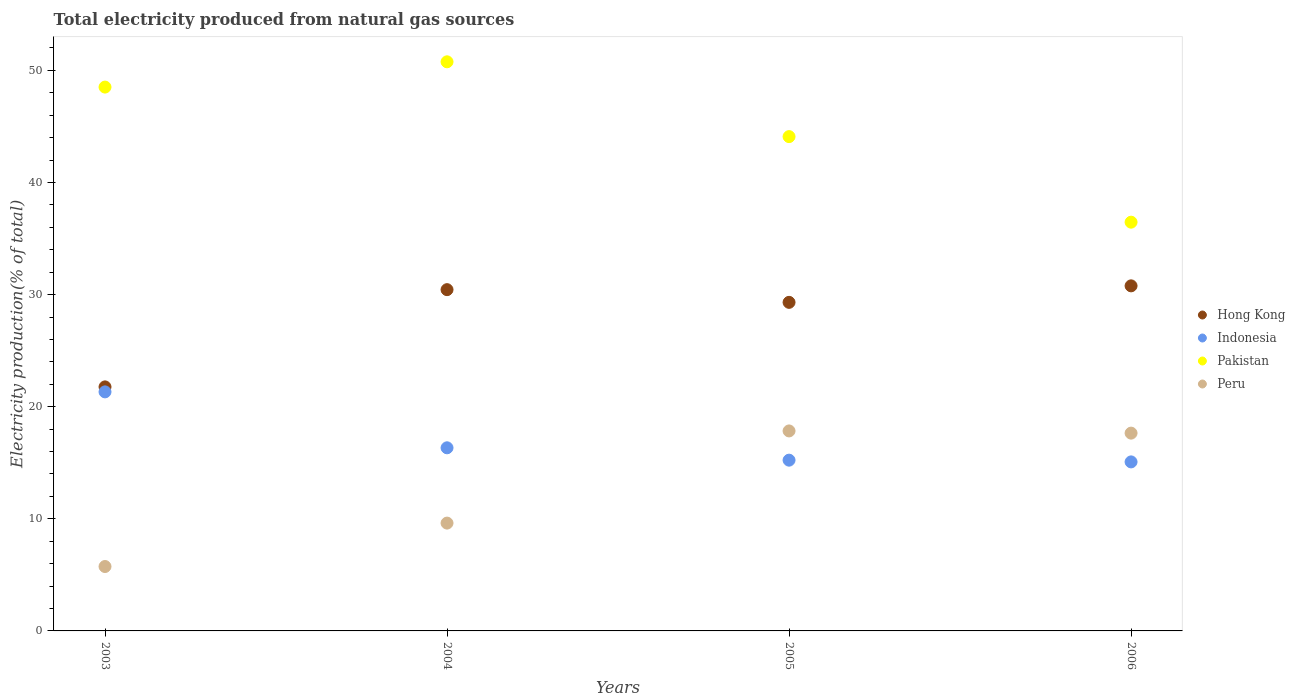Is the number of dotlines equal to the number of legend labels?
Provide a succinct answer. Yes. What is the total electricity produced in Pakistan in 2005?
Keep it short and to the point. 44.1. Across all years, what is the maximum total electricity produced in Peru?
Offer a very short reply. 17.84. Across all years, what is the minimum total electricity produced in Indonesia?
Make the answer very short. 15.08. What is the total total electricity produced in Peru in the graph?
Offer a very short reply. 50.85. What is the difference between the total electricity produced in Pakistan in 2004 and that in 2005?
Provide a short and direct response. 6.67. What is the difference between the total electricity produced in Peru in 2006 and the total electricity produced in Hong Kong in 2005?
Offer a very short reply. -11.67. What is the average total electricity produced in Indonesia per year?
Provide a short and direct response. 16.99. In the year 2005, what is the difference between the total electricity produced in Pakistan and total electricity produced in Peru?
Give a very brief answer. 26.26. In how many years, is the total electricity produced in Hong Kong greater than 24 %?
Make the answer very short. 3. What is the ratio of the total electricity produced in Peru in 2003 to that in 2005?
Provide a short and direct response. 0.32. Is the difference between the total electricity produced in Pakistan in 2004 and 2005 greater than the difference between the total electricity produced in Peru in 2004 and 2005?
Offer a very short reply. Yes. What is the difference between the highest and the second highest total electricity produced in Pakistan?
Offer a terse response. 2.25. What is the difference between the highest and the lowest total electricity produced in Indonesia?
Offer a very short reply. 6.25. In how many years, is the total electricity produced in Indonesia greater than the average total electricity produced in Indonesia taken over all years?
Provide a short and direct response. 1. Is the sum of the total electricity produced in Hong Kong in 2004 and 2006 greater than the maximum total electricity produced in Pakistan across all years?
Your answer should be compact. Yes. Does the total electricity produced in Pakistan monotonically increase over the years?
Ensure brevity in your answer.  No. Is the total electricity produced in Peru strictly greater than the total electricity produced in Pakistan over the years?
Ensure brevity in your answer.  No. What is the difference between two consecutive major ticks on the Y-axis?
Offer a terse response. 10. Are the values on the major ticks of Y-axis written in scientific E-notation?
Keep it short and to the point. No. Does the graph contain any zero values?
Your response must be concise. No. How many legend labels are there?
Your response must be concise. 4. What is the title of the graph?
Your answer should be compact. Total electricity produced from natural gas sources. Does "Sudan" appear as one of the legend labels in the graph?
Make the answer very short. No. What is the Electricity production(% of total) of Hong Kong in 2003?
Keep it short and to the point. 21.77. What is the Electricity production(% of total) of Indonesia in 2003?
Give a very brief answer. 21.32. What is the Electricity production(% of total) of Pakistan in 2003?
Offer a very short reply. 48.51. What is the Electricity production(% of total) in Peru in 2003?
Provide a succinct answer. 5.75. What is the Electricity production(% of total) of Hong Kong in 2004?
Your answer should be very brief. 30.44. What is the Electricity production(% of total) of Indonesia in 2004?
Your answer should be compact. 16.34. What is the Electricity production(% of total) in Pakistan in 2004?
Offer a terse response. 50.77. What is the Electricity production(% of total) in Peru in 2004?
Your response must be concise. 9.62. What is the Electricity production(% of total) in Hong Kong in 2005?
Your response must be concise. 29.31. What is the Electricity production(% of total) in Indonesia in 2005?
Give a very brief answer. 15.23. What is the Electricity production(% of total) in Pakistan in 2005?
Provide a short and direct response. 44.1. What is the Electricity production(% of total) of Peru in 2005?
Your answer should be very brief. 17.84. What is the Electricity production(% of total) of Hong Kong in 2006?
Offer a terse response. 30.78. What is the Electricity production(% of total) of Indonesia in 2006?
Your answer should be compact. 15.08. What is the Electricity production(% of total) in Pakistan in 2006?
Provide a short and direct response. 36.46. What is the Electricity production(% of total) of Peru in 2006?
Make the answer very short. 17.64. Across all years, what is the maximum Electricity production(% of total) in Hong Kong?
Provide a succinct answer. 30.78. Across all years, what is the maximum Electricity production(% of total) in Indonesia?
Provide a succinct answer. 21.32. Across all years, what is the maximum Electricity production(% of total) of Pakistan?
Make the answer very short. 50.77. Across all years, what is the maximum Electricity production(% of total) of Peru?
Ensure brevity in your answer.  17.84. Across all years, what is the minimum Electricity production(% of total) of Hong Kong?
Provide a short and direct response. 21.77. Across all years, what is the minimum Electricity production(% of total) of Indonesia?
Ensure brevity in your answer.  15.08. Across all years, what is the minimum Electricity production(% of total) of Pakistan?
Your answer should be very brief. 36.46. Across all years, what is the minimum Electricity production(% of total) of Peru?
Offer a terse response. 5.75. What is the total Electricity production(% of total) in Hong Kong in the graph?
Your answer should be compact. 112.3. What is the total Electricity production(% of total) of Indonesia in the graph?
Your answer should be compact. 67.97. What is the total Electricity production(% of total) in Pakistan in the graph?
Your answer should be very brief. 179.84. What is the total Electricity production(% of total) in Peru in the graph?
Provide a short and direct response. 50.85. What is the difference between the Electricity production(% of total) of Hong Kong in 2003 and that in 2004?
Ensure brevity in your answer.  -8.67. What is the difference between the Electricity production(% of total) in Indonesia in 2003 and that in 2004?
Ensure brevity in your answer.  4.99. What is the difference between the Electricity production(% of total) of Pakistan in 2003 and that in 2004?
Provide a succinct answer. -2.25. What is the difference between the Electricity production(% of total) of Peru in 2003 and that in 2004?
Offer a very short reply. -3.87. What is the difference between the Electricity production(% of total) in Hong Kong in 2003 and that in 2005?
Your response must be concise. -7.54. What is the difference between the Electricity production(% of total) in Indonesia in 2003 and that in 2005?
Your response must be concise. 6.09. What is the difference between the Electricity production(% of total) of Pakistan in 2003 and that in 2005?
Your answer should be very brief. 4.42. What is the difference between the Electricity production(% of total) of Peru in 2003 and that in 2005?
Make the answer very short. -12.09. What is the difference between the Electricity production(% of total) in Hong Kong in 2003 and that in 2006?
Your answer should be very brief. -9.01. What is the difference between the Electricity production(% of total) in Indonesia in 2003 and that in 2006?
Your answer should be compact. 6.25. What is the difference between the Electricity production(% of total) of Pakistan in 2003 and that in 2006?
Give a very brief answer. 12.05. What is the difference between the Electricity production(% of total) in Peru in 2003 and that in 2006?
Keep it short and to the point. -11.9. What is the difference between the Electricity production(% of total) in Hong Kong in 2004 and that in 2005?
Your answer should be very brief. 1.13. What is the difference between the Electricity production(% of total) of Indonesia in 2004 and that in 2005?
Offer a terse response. 1.1. What is the difference between the Electricity production(% of total) of Pakistan in 2004 and that in 2005?
Your answer should be compact. 6.67. What is the difference between the Electricity production(% of total) of Peru in 2004 and that in 2005?
Offer a very short reply. -8.22. What is the difference between the Electricity production(% of total) of Hong Kong in 2004 and that in 2006?
Offer a terse response. -0.34. What is the difference between the Electricity production(% of total) of Indonesia in 2004 and that in 2006?
Provide a succinct answer. 1.26. What is the difference between the Electricity production(% of total) in Pakistan in 2004 and that in 2006?
Your answer should be very brief. 14.31. What is the difference between the Electricity production(% of total) in Peru in 2004 and that in 2006?
Make the answer very short. -8.03. What is the difference between the Electricity production(% of total) in Hong Kong in 2005 and that in 2006?
Give a very brief answer. -1.47. What is the difference between the Electricity production(% of total) of Indonesia in 2005 and that in 2006?
Your answer should be compact. 0.16. What is the difference between the Electricity production(% of total) in Pakistan in 2005 and that in 2006?
Your answer should be compact. 7.63. What is the difference between the Electricity production(% of total) in Peru in 2005 and that in 2006?
Offer a very short reply. 0.2. What is the difference between the Electricity production(% of total) of Hong Kong in 2003 and the Electricity production(% of total) of Indonesia in 2004?
Provide a succinct answer. 5.43. What is the difference between the Electricity production(% of total) in Hong Kong in 2003 and the Electricity production(% of total) in Pakistan in 2004?
Your answer should be very brief. -29. What is the difference between the Electricity production(% of total) in Hong Kong in 2003 and the Electricity production(% of total) in Peru in 2004?
Make the answer very short. 12.15. What is the difference between the Electricity production(% of total) of Indonesia in 2003 and the Electricity production(% of total) of Pakistan in 2004?
Provide a succinct answer. -29.44. What is the difference between the Electricity production(% of total) of Indonesia in 2003 and the Electricity production(% of total) of Peru in 2004?
Give a very brief answer. 11.71. What is the difference between the Electricity production(% of total) of Pakistan in 2003 and the Electricity production(% of total) of Peru in 2004?
Your answer should be very brief. 38.89. What is the difference between the Electricity production(% of total) in Hong Kong in 2003 and the Electricity production(% of total) in Indonesia in 2005?
Your answer should be compact. 6.54. What is the difference between the Electricity production(% of total) of Hong Kong in 2003 and the Electricity production(% of total) of Pakistan in 2005?
Keep it short and to the point. -22.33. What is the difference between the Electricity production(% of total) of Hong Kong in 2003 and the Electricity production(% of total) of Peru in 2005?
Your answer should be very brief. 3.93. What is the difference between the Electricity production(% of total) of Indonesia in 2003 and the Electricity production(% of total) of Pakistan in 2005?
Provide a short and direct response. -22.77. What is the difference between the Electricity production(% of total) of Indonesia in 2003 and the Electricity production(% of total) of Peru in 2005?
Your response must be concise. 3.48. What is the difference between the Electricity production(% of total) of Pakistan in 2003 and the Electricity production(% of total) of Peru in 2005?
Keep it short and to the point. 30.67. What is the difference between the Electricity production(% of total) of Hong Kong in 2003 and the Electricity production(% of total) of Indonesia in 2006?
Offer a terse response. 6.69. What is the difference between the Electricity production(% of total) in Hong Kong in 2003 and the Electricity production(% of total) in Pakistan in 2006?
Provide a succinct answer. -14.69. What is the difference between the Electricity production(% of total) of Hong Kong in 2003 and the Electricity production(% of total) of Peru in 2006?
Provide a short and direct response. 4.13. What is the difference between the Electricity production(% of total) in Indonesia in 2003 and the Electricity production(% of total) in Pakistan in 2006?
Offer a very short reply. -15.14. What is the difference between the Electricity production(% of total) of Indonesia in 2003 and the Electricity production(% of total) of Peru in 2006?
Provide a succinct answer. 3.68. What is the difference between the Electricity production(% of total) of Pakistan in 2003 and the Electricity production(% of total) of Peru in 2006?
Your answer should be compact. 30.87. What is the difference between the Electricity production(% of total) in Hong Kong in 2004 and the Electricity production(% of total) in Indonesia in 2005?
Provide a short and direct response. 15.21. What is the difference between the Electricity production(% of total) of Hong Kong in 2004 and the Electricity production(% of total) of Pakistan in 2005?
Offer a very short reply. -13.65. What is the difference between the Electricity production(% of total) in Hong Kong in 2004 and the Electricity production(% of total) in Peru in 2005?
Your response must be concise. 12.6. What is the difference between the Electricity production(% of total) of Indonesia in 2004 and the Electricity production(% of total) of Pakistan in 2005?
Provide a succinct answer. -27.76. What is the difference between the Electricity production(% of total) in Indonesia in 2004 and the Electricity production(% of total) in Peru in 2005?
Provide a succinct answer. -1.5. What is the difference between the Electricity production(% of total) of Pakistan in 2004 and the Electricity production(% of total) of Peru in 2005?
Provide a short and direct response. 32.93. What is the difference between the Electricity production(% of total) in Hong Kong in 2004 and the Electricity production(% of total) in Indonesia in 2006?
Your answer should be very brief. 15.37. What is the difference between the Electricity production(% of total) in Hong Kong in 2004 and the Electricity production(% of total) in Pakistan in 2006?
Your answer should be compact. -6.02. What is the difference between the Electricity production(% of total) of Hong Kong in 2004 and the Electricity production(% of total) of Peru in 2006?
Your answer should be very brief. 12.8. What is the difference between the Electricity production(% of total) of Indonesia in 2004 and the Electricity production(% of total) of Pakistan in 2006?
Provide a short and direct response. -20.13. What is the difference between the Electricity production(% of total) in Indonesia in 2004 and the Electricity production(% of total) in Peru in 2006?
Ensure brevity in your answer.  -1.31. What is the difference between the Electricity production(% of total) of Pakistan in 2004 and the Electricity production(% of total) of Peru in 2006?
Your answer should be compact. 33.12. What is the difference between the Electricity production(% of total) in Hong Kong in 2005 and the Electricity production(% of total) in Indonesia in 2006?
Ensure brevity in your answer.  14.23. What is the difference between the Electricity production(% of total) of Hong Kong in 2005 and the Electricity production(% of total) of Pakistan in 2006?
Offer a terse response. -7.15. What is the difference between the Electricity production(% of total) in Hong Kong in 2005 and the Electricity production(% of total) in Peru in 2006?
Your answer should be compact. 11.67. What is the difference between the Electricity production(% of total) in Indonesia in 2005 and the Electricity production(% of total) in Pakistan in 2006?
Give a very brief answer. -21.23. What is the difference between the Electricity production(% of total) of Indonesia in 2005 and the Electricity production(% of total) of Peru in 2006?
Offer a terse response. -2.41. What is the difference between the Electricity production(% of total) in Pakistan in 2005 and the Electricity production(% of total) in Peru in 2006?
Provide a succinct answer. 26.45. What is the average Electricity production(% of total) in Hong Kong per year?
Give a very brief answer. 28.08. What is the average Electricity production(% of total) in Indonesia per year?
Keep it short and to the point. 16.99. What is the average Electricity production(% of total) in Pakistan per year?
Ensure brevity in your answer.  44.96. What is the average Electricity production(% of total) in Peru per year?
Provide a short and direct response. 12.71. In the year 2003, what is the difference between the Electricity production(% of total) of Hong Kong and Electricity production(% of total) of Indonesia?
Offer a terse response. 0.44. In the year 2003, what is the difference between the Electricity production(% of total) of Hong Kong and Electricity production(% of total) of Pakistan?
Your response must be concise. -26.74. In the year 2003, what is the difference between the Electricity production(% of total) in Hong Kong and Electricity production(% of total) in Peru?
Your answer should be very brief. 16.02. In the year 2003, what is the difference between the Electricity production(% of total) of Indonesia and Electricity production(% of total) of Pakistan?
Your response must be concise. -27.19. In the year 2003, what is the difference between the Electricity production(% of total) of Indonesia and Electricity production(% of total) of Peru?
Your answer should be compact. 15.58. In the year 2003, what is the difference between the Electricity production(% of total) in Pakistan and Electricity production(% of total) in Peru?
Your response must be concise. 42.77. In the year 2004, what is the difference between the Electricity production(% of total) of Hong Kong and Electricity production(% of total) of Indonesia?
Ensure brevity in your answer.  14.11. In the year 2004, what is the difference between the Electricity production(% of total) in Hong Kong and Electricity production(% of total) in Pakistan?
Give a very brief answer. -20.33. In the year 2004, what is the difference between the Electricity production(% of total) in Hong Kong and Electricity production(% of total) in Peru?
Give a very brief answer. 20.82. In the year 2004, what is the difference between the Electricity production(% of total) in Indonesia and Electricity production(% of total) in Pakistan?
Offer a very short reply. -34.43. In the year 2004, what is the difference between the Electricity production(% of total) in Indonesia and Electricity production(% of total) in Peru?
Your answer should be compact. 6.72. In the year 2004, what is the difference between the Electricity production(% of total) of Pakistan and Electricity production(% of total) of Peru?
Keep it short and to the point. 41.15. In the year 2005, what is the difference between the Electricity production(% of total) in Hong Kong and Electricity production(% of total) in Indonesia?
Make the answer very short. 14.08. In the year 2005, what is the difference between the Electricity production(% of total) of Hong Kong and Electricity production(% of total) of Pakistan?
Provide a short and direct response. -14.79. In the year 2005, what is the difference between the Electricity production(% of total) of Hong Kong and Electricity production(% of total) of Peru?
Give a very brief answer. 11.47. In the year 2005, what is the difference between the Electricity production(% of total) in Indonesia and Electricity production(% of total) in Pakistan?
Your answer should be compact. -28.86. In the year 2005, what is the difference between the Electricity production(% of total) of Indonesia and Electricity production(% of total) of Peru?
Give a very brief answer. -2.61. In the year 2005, what is the difference between the Electricity production(% of total) of Pakistan and Electricity production(% of total) of Peru?
Provide a succinct answer. 26.26. In the year 2006, what is the difference between the Electricity production(% of total) of Hong Kong and Electricity production(% of total) of Indonesia?
Keep it short and to the point. 15.7. In the year 2006, what is the difference between the Electricity production(% of total) of Hong Kong and Electricity production(% of total) of Pakistan?
Your answer should be very brief. -5.68. In the year 2006, what is the difference between the Electricity production(% of total) of Hong Kong and Electricity production(% of total) of Peru?
Your answer should be compact. 13.14. In the year 2006, what is the difference between the Electricity production(% of total) in Indonesia and Electricity production(% of total) in Pakistan?
Your response must be concise. -21.38. In the year 2006, what is the difference between the Electricity production(% of total) in Indonesia and Electricity production(% of total) in Peru?
Provide a succinct answer. -2.57. In the year 2006, what is the difference between the Electricity production(% of total) of Pakistan and Electricity production(% of total) of Peru?
Keep it short and to the point. 18.82. What is the ratio of the Electricity production(% of total) in Hong Kong in 2003 to that in 2004?
Offer a terse response. 0.72. What is the ratio of the Electricity production(% of total) of Indonesia in 2003 to that in 2004?
Ensure brevity in your answer.  1.31. What is the ratio of the Electricity production(% of total) in Pakistan in 2003 to that in 2004?
Provide a succinct answer. 0.96. What is the ratio of the Electricity production(% of total) of Peru in 2003 to that in 2004?
Offer a terse response. 0.6. What is the ratio of the Electricity production(% of total) in Hong Kong in 2003 to that in 2005?
Make the answer very short. 0.74. What is the ratio of the Electricity production(% of total) in Indonesia in 2003 to that in 2005?
Your answer should be very brief. 1.4. What is the ratio of the Electricity production(% of total) of Pakistan in 2003 to that in 2005?
Offer a very short reply. 1.1. What is the ratio of the Electricity production(% of total) in Peru in 2003 to that in 2005?
Your answer should be very brief. 0.32. What is the ratio of the Electricity production(% of total) in Hong Kong in 2003 to that in 2006?
Offer a terse response. 0.71. What is the ratio of the Electricity production(% of total) in Indonesia in 2003 to that in 2006?
Your response must be concise. 1.41. What is the ratio of the Electricity production(% of total) of Pakistan in 2003 to that in 2006?
Your response must be concise. 1.33. What is the ratio of the Electricity production(% of total) of Peru in 2003 to that in 2006?
Give a very brief answer. 0.33. What is the ratio of the Electricity production(% of total) in Hong Kong in 2004 to that in 2005?
Provide a succinct answer. 1.04. What is the ratio of the Electricity production(% of total) of Indonesia in 2004 to that in 2005?
Ensure brevity in your answer.  1.07. What is the ratio of the Electricity production(% of total) of Pakistan in 2004 to that in 2005?
Your answer should be very brief. 1.15. What is the ratio of the Electricity production(% of total) of Peru in 2004 to that in 2005?
Your response must be concise. 0.54. What is the ratio of the Electricity production(% of total) in Indonesia in 2004 to that in 2006?
Make the answer very short. 1.08. What is the ratio of the Electricity production(% of total) of Pakistan in 2004 to that in 2006?
Make the answer very short. 1.39. What is the ratio of the Electricity production(% of total) in Peru in 2004 to that in 2006?
Provide a short and direct response. 0.55. What is the ratio of the Electricity production(% of total) in Hong Kong in 2005 to that in 2006?
Your response must be concise. 0.95. What is the ratio of the Electricity production(% of total) of Indonesia in 2005 to that in 2006?
Your answer should be compact. 1.01. What is the ratio of the Electricity production(% of total) of Pakistan in 2005 to that in 2006?
Your response must be concise. 1.21. What is the ratio of the Electricity production(% of total) in Peru in 2005 to that in 2006?
Your response must be concise. 1.01. What is the difference between the highest and the second highest Electricity production(% of total) in Hong Kong?
Your response must be concise. 0.34. What is the difference between the highest and the second highest Electricity production(% of total) in Indonesia?
Offer a very short reply. 4.99. What is the difference between the highest and the second highest Electricity production(% of total) in Pakistan?
Your response must be concise. 2.25. What is the difference between the highest and the second highest Electricity production(% of total) of Peru?
Provide a short and direct response. 0.2. What is the difference between the highest and the lowest Electricity production(% of total) of Hong Kong?
Give a very brief answer. 9.01. What is the difference between the highest and the lowest Electricity production(% of total) of Indonesia?
Keep it short and to the point. 6.25. What is the difference between the highest and the lowest Electricity production(% of total) in Pakistan?
Provide a succinct answer. 14.31. What is the difference between the highest and the lowest Electricity production(% of total) in Peru?
Provide a succinct answer. 12.09. 